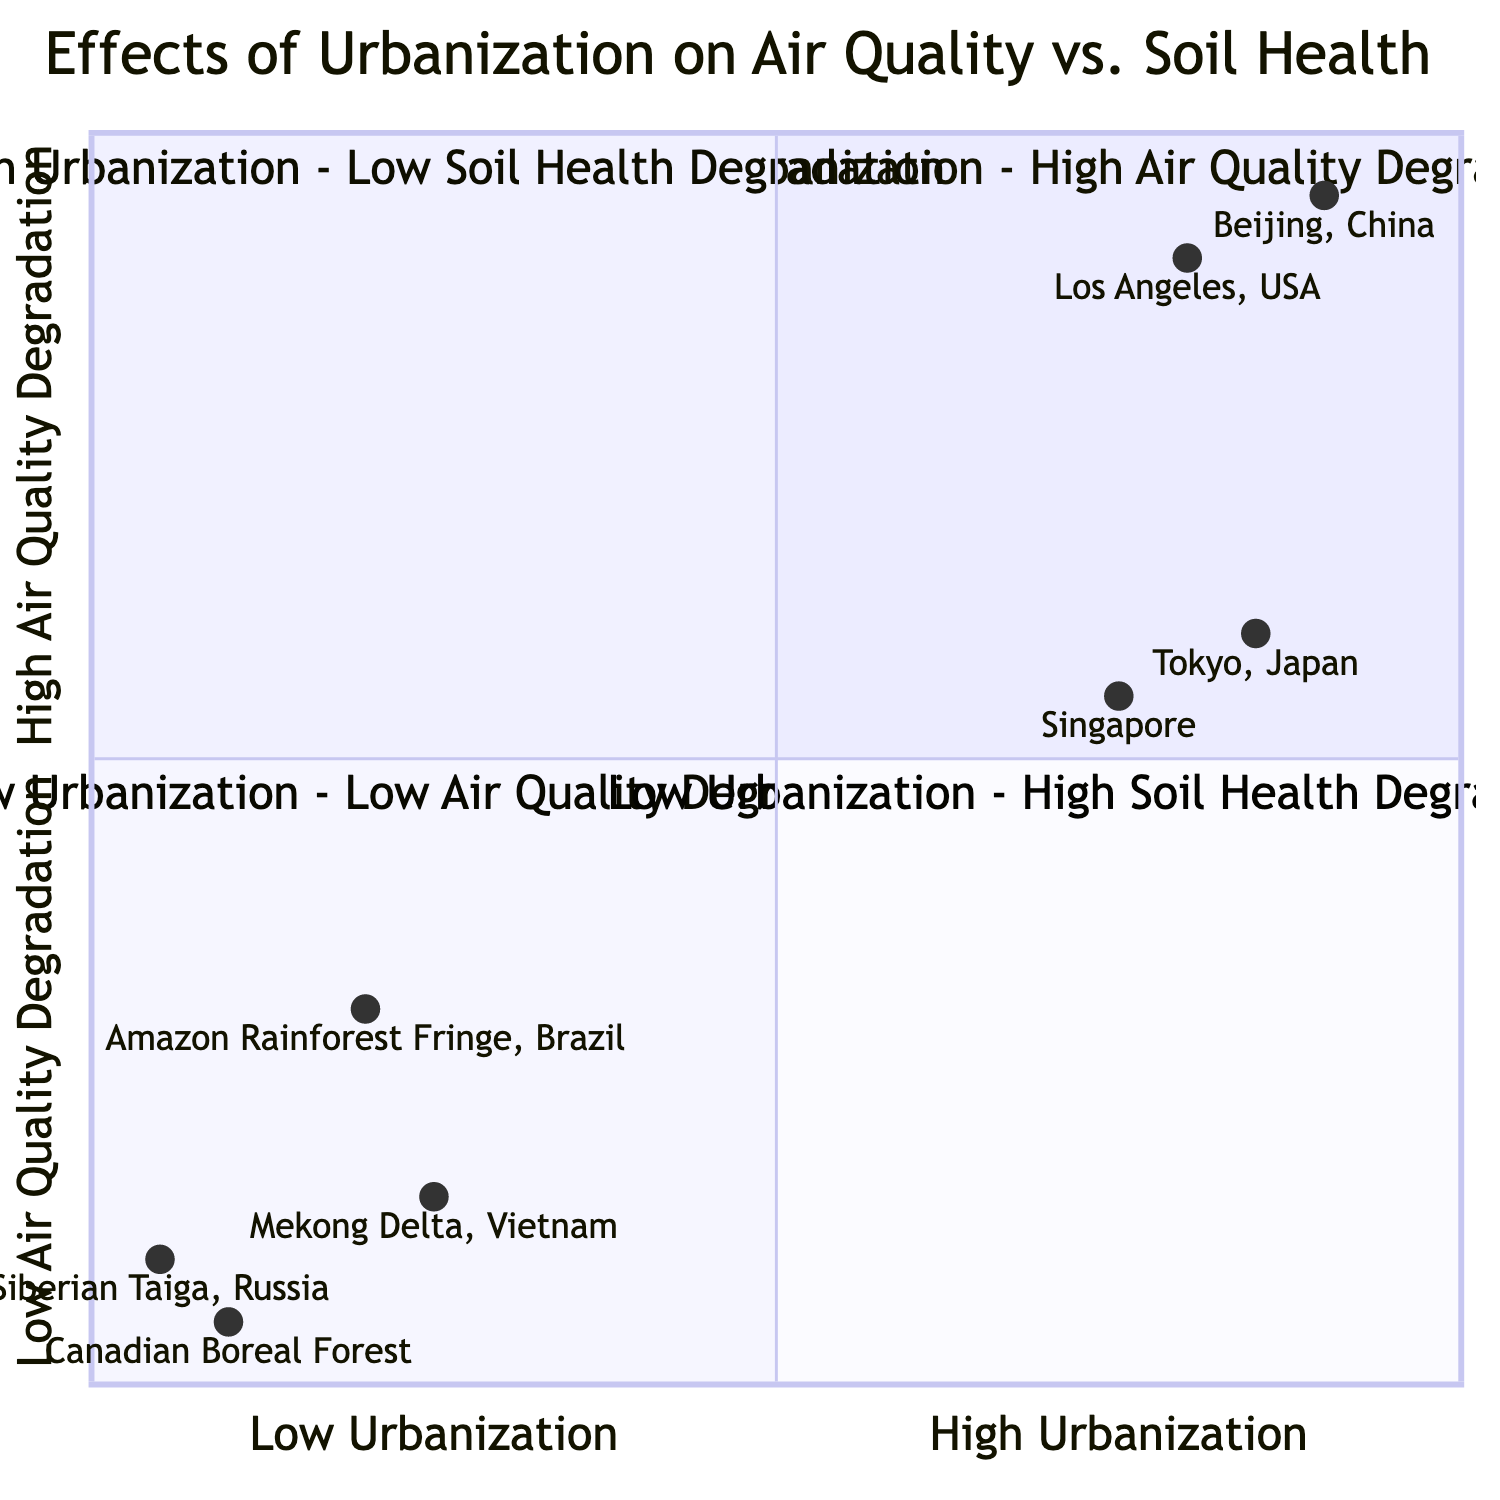What regions are in the "High Urbanization - High Air Quality Degradation" quadrant? The "High Urbanization - High Air Quality Degradation" quadrant contains regions that show both high urbanization and severe degradation in air quality. From the diagram, these regions are Los Angeles, USA and Beijing, China.
Answer: Los Angeles, USA; Beijing, China Which region has the lowest air quality impact in the diagram? The region with the lowest air quality impact is the Canadian Boreal Forest, which is noted for its pristine air quality. This determination is made by comparing the air quality impacts listed for each region in the quadrants.
Answer: Canadian Boreal Forest How many regions are classified under "High Urbanization - Low Soil Health Degradation"? This quadrant has two regions: Tokyo, Japan and Singapore. Therefore, by counting the regions listed under this specific quadrant, we can conclude there are two.
Answer: 2 What soil health impact is noted for "Amazon Rainforest Fringe, Brazil"? The soil health impact for the Amazon Rainforest Fringe, Brazil is a loss of soil fertility due to deforestation. This is directly taken from the data presented in the "Low Urbanization - High Soil Health Degradation" quadrant.
Answer: Loss of soil fertility due to deforestation Which quadrant contains regions with both urbanization and air quality impacts on the lower end? The quadrant that contains regions with both low urbanization and low air quality degradation is the "Low Urbanization - Low Air Quality Degradation" quadrant. It includes regions like Canadian Boreal Forest and Siberian Taiga, Russia, indicating minimal impacts in both factors.
Answer: Low Urbanization - Low Air Quality Degradation What is the air quality impact of Tokyo, Japan? The air quality impact of Tokyo, Japan is noted as moderate levels of Ozone and SO2. This information helps categorize the region under the "High Urbanization - Low Soil Health Degradation" quadrant.
Answer: Moderate levels of Ozone and SO2 Which region among those with high urbanization shows well-maintained soil health? The region that displays well-maintained soil health despite high urbanization is Tokyo, Japan. This is apparent when analyzing the soil health impact listed under the "High Urbanization - Low Soil Health Degradation" quadrant.
Answer: Tokyo, Japan What is the relationship between urbanization and soil health for Mekong Delta, Vietnam? The Mekong Delta, Vietnam illustrates a situation where, despite low urbanization, there is a high degradation in soil health due to intensive agriculture leading to soil salinization. This establishes a notable relationship where low urbanization does not correlate to high soil health.
Answer: Low urbanization - high soil health degradation What is the air quality impact of Singapore and how does it compare to Tokyo? Singapore experiences seasonal haze from regional fires, which is lower than Tokyo’s moderate levels of Ozone and SO2. This implies that while both regions are urbanized, Singapore's air quality impact is less severe than that of Tokyo.
Answer: Seasonal haze from regional fires; lower than Tokyo 